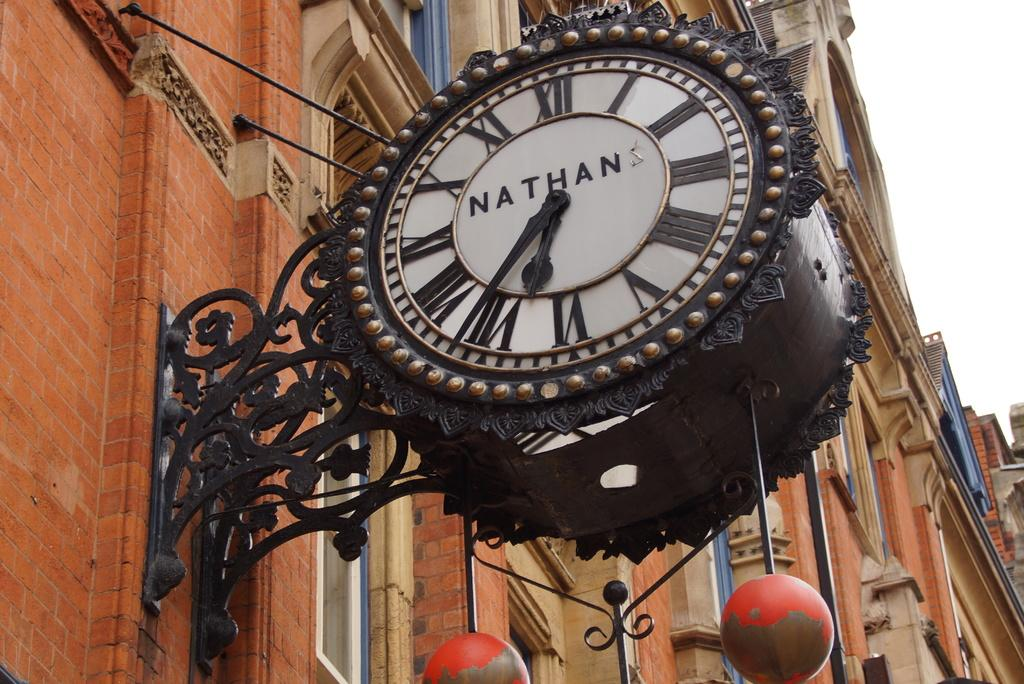<image>
Write a terse but informative summary of the picture. A black clock that says NATHAN hangs from a brick wall 